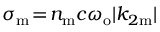Convert formula to latex. <formula><loc_0><loc_0><loc_500><loc_500>\sigma _ { m } \, = \, n _ { m } c \omega _ { o } | k _ { 2 m } |</formula> 